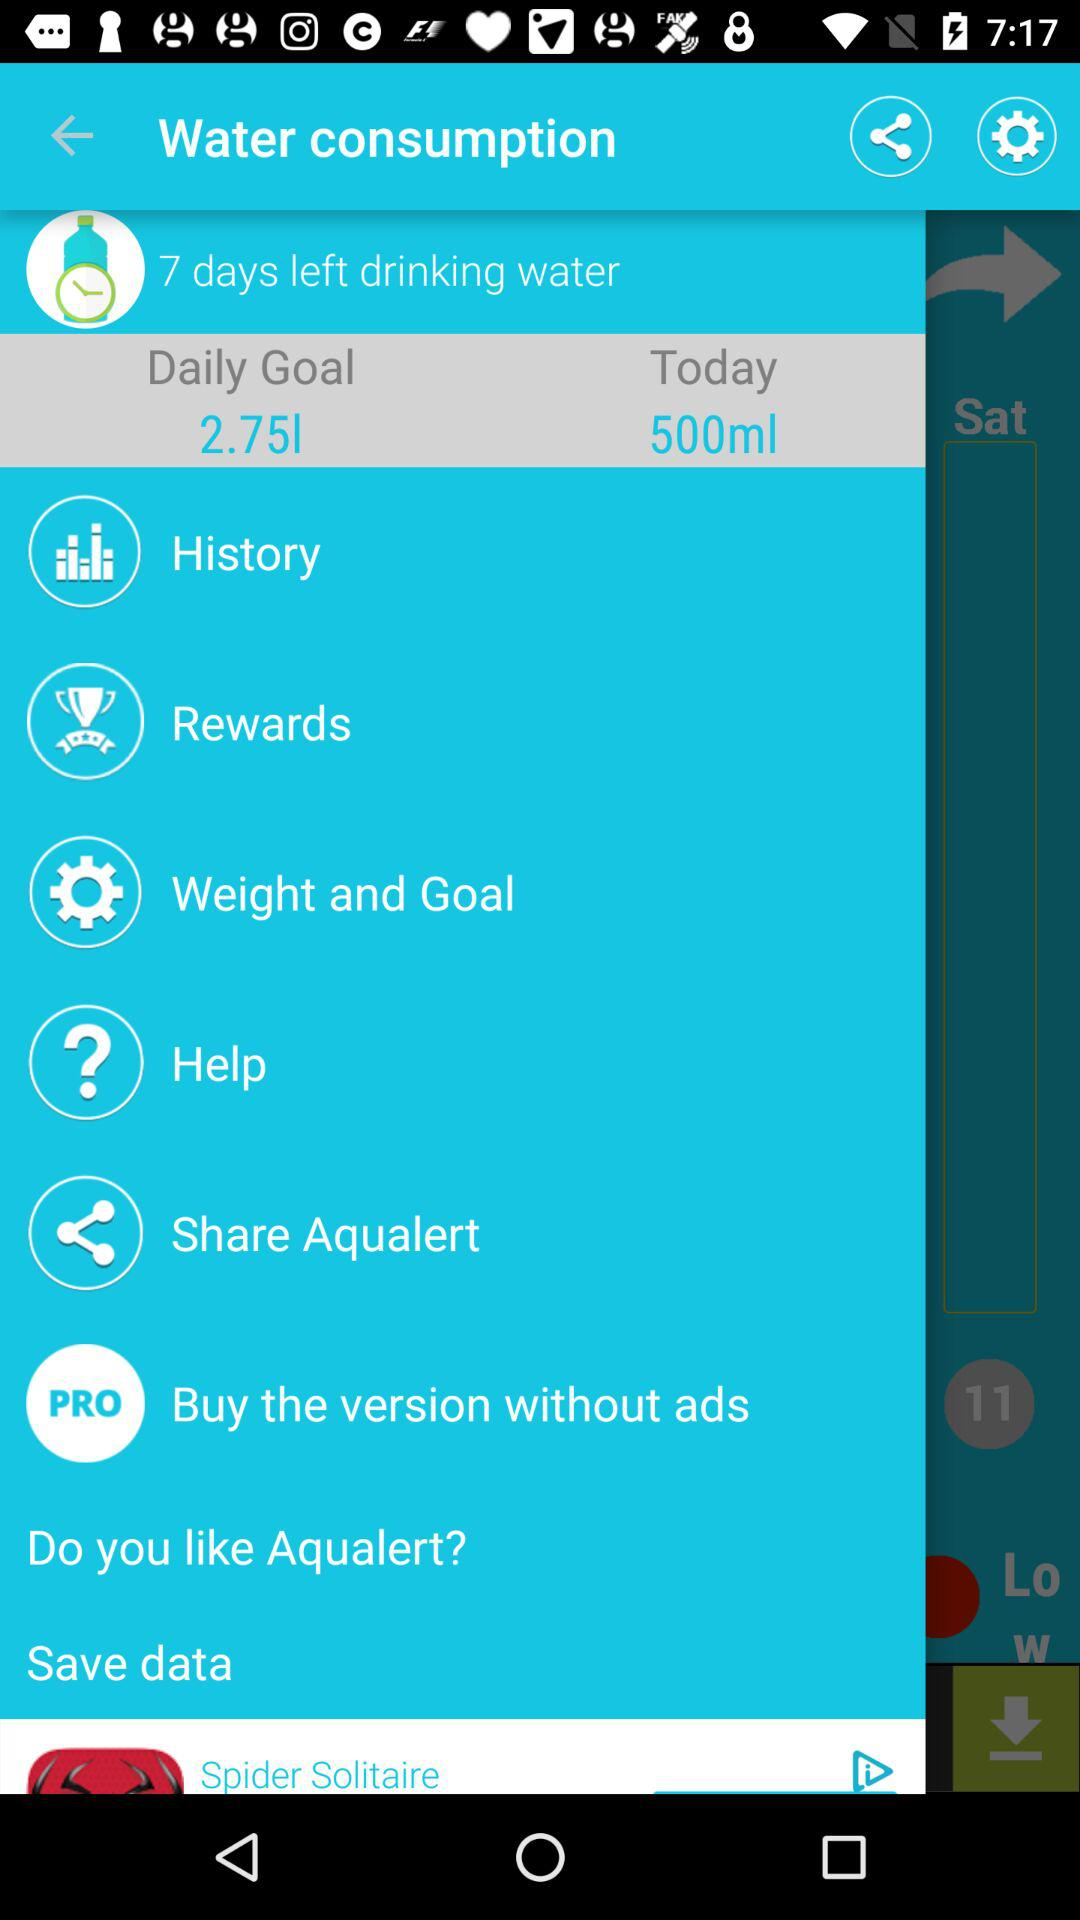What is the daily goal? The daily goal is 2.75 litres. 